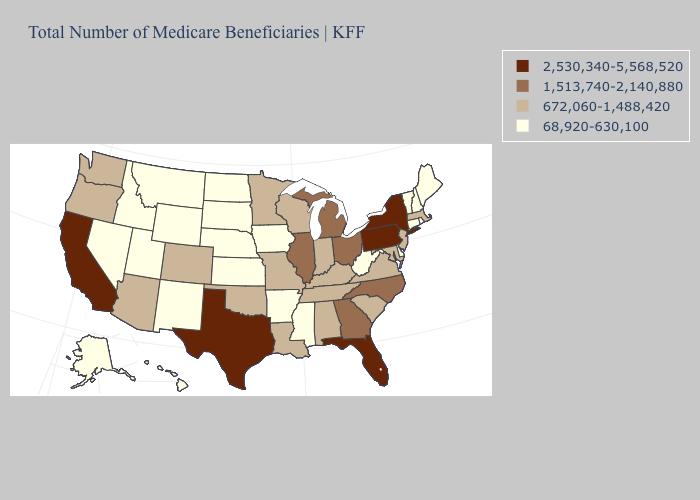Does Colorado have a higher value than Oklahoma?
Concise answer only. No. What is the value of Arkansas?
Give a very brief answer. 68,920-630,100. What is the value of Rhode Island?
Be succinct. 68,920-630,100. Does Idaho have the same value as Georgia?
Keep it brief. No. What is the highest value in the USA?
Answer briefly. 2,530,340-5,568,520. Does West Virginia have the same value as Indiana?
Be succinct. No. What is the value of Arizona?
Be succinct. 672,060-1,488,420. Does Michigan have the highest value in the MidWest?
Concise answer only. Yes. What is the value of Maine?
Give a very brief answer. 68,920-630,100. What is the value of Alabama?
Quick response, please. 672,060-1,488,420. Does Utah have the highest value in the West?
Answer briefly. No. What is the value of Missouri?
Be succinct. 672,060-1,488,420. Name the states that have a value in the range 2,530,340-5,568,520?
Be succinct. California, Florida, New York, Pennsylvania, Texas. Does Alaska have the same value as South Dakota?
Write a very short answer. Yes. 